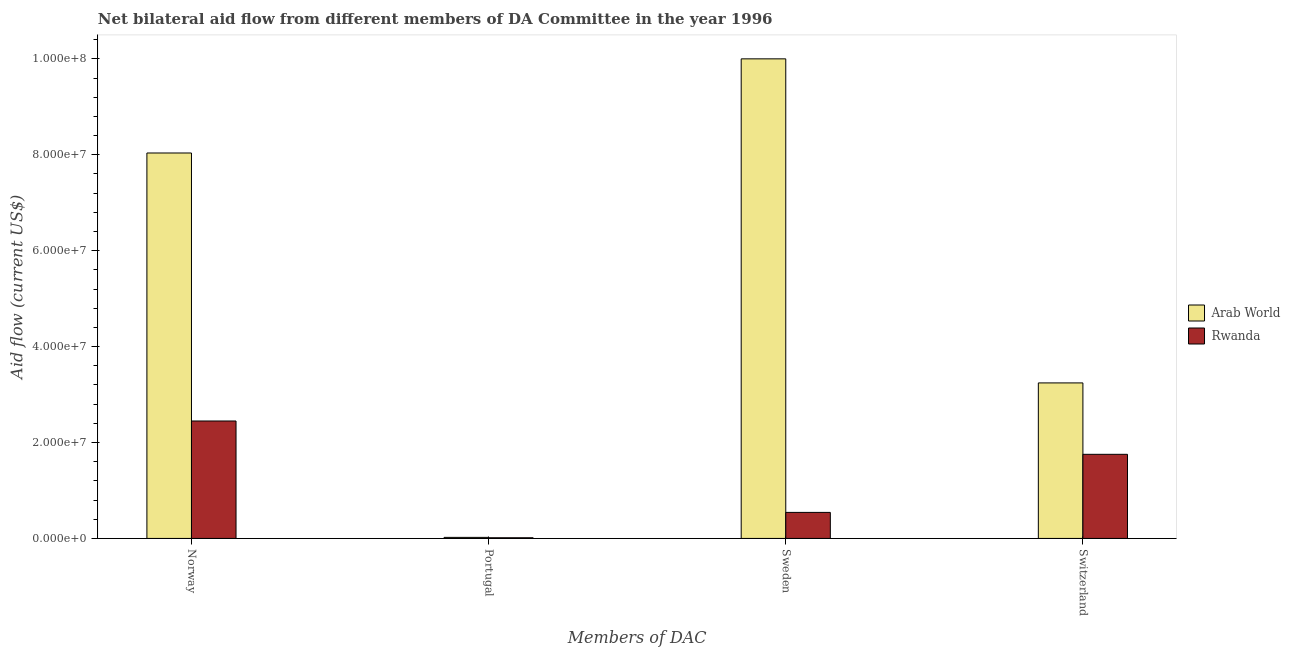How many groups of bars are there?
Your response must be concise. 4. What is the label of the 4th group of bars from the left?
Your answer should be compact. Switzerland. What is the amount of aid given by portugal in Rwanda?
Provide a short and direct response. 1.40e+05. Across all countries, what is the maximum amount of aid given by switzerland?
Your response must be concise. 3.24e+07. Across all countries, what is the minimum amount of aid given by switzerland?
Offer a terse response. 1.75e+07. In which country was the amount of aid given by sweden maximum?
Provide a short and direct response. Arab World. In which country was the amount of aid given by portugal minimum?
Offer a terse response. Rwanda. What is the total amount of aid given by sweden in the graph?
Your response must be concise. 1.05e+08. What is the difference between the amount of aid given by norway in Arab World and that in Rwanda?
Your answer should be compact. 5.59e+07. What is the difference between the amount of aid given by portugal in Arab World and the amount of aid given by sweden in Rwanda?
Your response must be concise. -5.21e+06. What is the average amount of aid given by norway per country?
Offer a very short reply. 5.24e+07. What is the difference between the amount of aid given by norway and amount of aid given by sweden in Arab World?
Your response must be concise. -1.96e+07. In how many countries, is the amount of aid given by switzerland greater than 16000000 US$?
Offer a very short reply. 2. What is the ratio of the amount of aid given by sweden in Arab World to that in Rwanda?
Your answer should be compact. 18.42. What is the difference between the highest and the second highest amount of aid given by norway?
Your answer should be compact. 5.59e+07. What is the difference between the highest and the lowest amount of aid given by sweden?
Your response must be concise. 9.46e+07. In how many countries, is the amount of aid given by portugal greater than the average amount of aid given by portugal taken over all countries?
Your answer should be very brief. 1. Is the sum of the amount of aid given by norway in Rwanda and Arab World greater than the maximum amount of aid given by portugal across all countries?
Keep it short and to the point. Yes. What does the 2nd bar from the left in Switzerland represents?
Provide a short and direct response. Rwanda. What does the 1st bar from the right in Portugal represents?
Offer a terse response. Rwanda. How many bars are there?
Provide a succinct answer. 8. Are the values on the major ticks of Y-axis written in scientific E-notation?
Ensure brevity in your answer.  Yes. Does the graph contain grids?
Keep it short and to the point. No. Where does the legend appear in the graph?
Your answer should be compact. Center right. How are the legend labels stacked?
Keep it short and to the point. Vertical. What is the title of the graph?
Offer a very short reply. Net bilateral aid flow from different members of DA Committee in the year 1996. Does "Pakistan" appear as one of the legend labels in the graph?
Offer a very short reply. No. What is the label or title of the X-axis?
Your answer should be compact. Members of DAC. What is the label or title of the Y-axis?
Your answer should be compact. Aid flow (current US$). What is the Aid flow (current US$) of Arab World in Norway?
Your response must be concise. 8.04e+07. What is the Aid flow (current US$) in Rwanda in Norway?
Ensure brevity in your answer.  2.45e+07. What is the Aid flow (current US$) in Rwanda in Portugal?
Keep it short and to the point. 1.40e+05. What is the Aid flow (current US$) of Arab World in Sweden?
Your answer should be compact. 1.00e+08. What is the Aid flow (current US$) in Rwanda in Sweden?
Offer a very short reply. 5.43e+06. What is the Aid flow (current US$) of Arab World in Switzerland?
Your response must be concise. 3.24e+07. What is the Aid flow (current US$) in Rwanda in Switzerland?
Make the answer very short. 1.75e+07. Across all Members of DAC, what is the maximum Aid flow (current US$) of Arab World?
Your answer should be compact. 1.00e+08. Across all Members of DAC, what is the maximum Aid flow (current US$) in Rwanda?
Make the answer very short. 2.45e+07. Across all Members of DAC, what is the minimum Aid flow (current US$) of Rwanda?
Provide a short and direct response. 1.40e+05. What is the total Aid flow (current US$) of Arab World in the graph?
Offer a very short reply. 2.13e+08. What is the total Aid flow (current US$) in Rwanda in the graph?
Provide a short and direct response. 4.76e+07. What is the difference between the Aid flow (current US$) in Arab World in Norway and that in Portugal?
Give a very brief answer. 8.02e+07. What is the difference between the Aid flow (current US$) of Rwanda in Norway and that in Portugal?
Provide a short and direct response. 2.44e+07. What is the difference between the Aid flow (current US$) in Arab World in Norway and that in Sweden?
Give a very brief answer. -1.96e+07. What is the difference between the Aid flow (current US$) in Rwanda in Norway and that in Sweden?
Give a very brief answer. 1.91e+07. What is the difference between the Aid flow (current US$) in Arab World in Norway and that in Switzerland?
Provide a short and direct response. 4.80e+07. What is the difference between the Aid flow (current US$) of Rwanda in Norway and that in Switzerland?
Keep it short and to the point. 6.95e+06. What is the difference between the Aid flow (current US$) of Arab World in Portugal and that in Sweden?
Provide a succinct answer. -9.98e+07. What is the difference between the Aid flow (current US$) of Rwanda in Portugal and that in Sweden?
Keep it short and to the point. -5.29e+06. What is the difference between the Aid flow (current US$) of Arab World in Portugal and that in Switzerland?
Offer a terse response. -3.22e+07. What is the difference between the Aid flow (current US$) of Rwanda in Portugal and that in Switzerland?
Provide a succinct answer. -1.74e+07. What is the difference between the Aid flow (current US$) of Arab World in Sweden and that in Switzerland?
Provide a short and direct response. 6.76e+07. What is the difference between the Aid flow (current US$) in Rwanda in Sweden and that in Switzerland?
Ensure brevity in your answer.  -1.21e+07. What is the difference between the Aid flow (current US$) in Arab World in Norway and the Aid flow (current US$) in Rwanda in Portugal?
Your answer should be very brief. 8.02e+07. What is the difference between the Aid flow (current US$) of Arab World in Norway and the Aid flow (current US$) of Rwanda in Sweden?
Give a very brief answer. 7.50e+07. What is the difference between the Aid flow (current US$) of Arab World in Norway and the Aid flow (current US$) of Rwanda in Switzerland?
Ensure brevity in your answer.  6.28e+07. What is the difference between the Aid flow (current US$) of Arab World in Portugal and the Aid flow (current US$) of Rwanda in Sweden?
Offer a terse response. -5.21e+06. What is the difference between the Aid flow (current US$) in Arab World in Portugal and the Aid flow (current US$) in Rwanda in Switzerland?
Provide a short and direct response. -1.73e+07. What is the difference between the Aid flow (current US$) in Arab World in Sweden and the Aid flow (current US$) in Rwanda in Switzerland?
Give a very brief answer. 8.25e+07. What is the average Aid flow (current US$) in Arab World per Members of DAC?
Your answer should be compact. 5.33e+07. What is the average Aid flow (current US$) in Rwanda per Members of DAC?
Offer a very short reply. 1.19e+07. What is the difference between the Aid flow (current US$) in Arab World and Aid flow (current US$) in Rwanda in Norway?
Your answer should be compact. 5.59e+07. What is the difference between the Aid flow (current US$) in Arab World and Aid flow (current US$) in Rwanda in Sweden?
Your answer should be compact. 9.46e+07. What is the difference between the Aid flow (current US$) in Arab World and Aid flow (current US$) in Rwanda in Switzerland?
Your answer should be very brief. 1.49e+07. What is the ratio of the Aid flow (current US$) of Arab World in Norway to that in Portugal?
Your answer should be very brief. 365.36. What is the ratio of the Aid flow (current US$) of Rwanda in Norway to that in Portugal?
Offer a very short reply. 174.93. What is the ratio of the Aid flow (current US$) in Arab World in Norway to that in Sweden?
Offer a terse response. 0.8. What is the ratio of the Aid flow (current US$) in Rwanda in Norway to that in Sweden?
Keep it short and to the point. 4.51. What is the ratio of the Aid flow (current US$) of Arab World in Norway to that in Switzerland?
Make the answer very short. 2.48. What is the ratio of the Aid flow (current US$) of Rwanda in Norway to that in Switzerland?
Give a very brief answer. 1.4. What is the ratio of the Aid flow (current US$) in Arab World in Portugal to that in Sweden?
Offer a very short reply. 0. What is the ratio of the Aid flow (current US$) in Rwanda in Portugal to that in Sweden?
Offer a terse response. 0.03. What is the ratio of the Aid flow (current US$) of Arab World in Portugal to that in Switzerland?
Keep it short and to the point. 0.01. What is the ratio of the Aid flow (current US$) of Rwanda in Portugal to that in Switzerland?
Your answer should be compact. 0.01. What is the ratio of the Aid flow (current US$) of Arab World in Sweden to that in Switzerland?
Your answer should be very brief. 3.08. What is the ratio of the Aid flow (current US$) in Rwanda in Sweden to that in Switzerland?
Provide a succinct answer. 0.31. What is the difference between the highest and the second highest Aid flow (current US$) in Arab World?
Your response must be concise. 1.96e+07. What is the difference between the highest and the second highest Aid flow (current US$) in Rwanda?
Your answer should be very brief. 6.95e+06. What is the difference between the highest and the lowest Aid flow (current US$) in Arab World?
Your answer should be compact. 9.98e+07. What is the difference between the highest and the lowest Aid flow (current US$) in Rwanda?
Your answer should be very brief. 2.44e+07. 